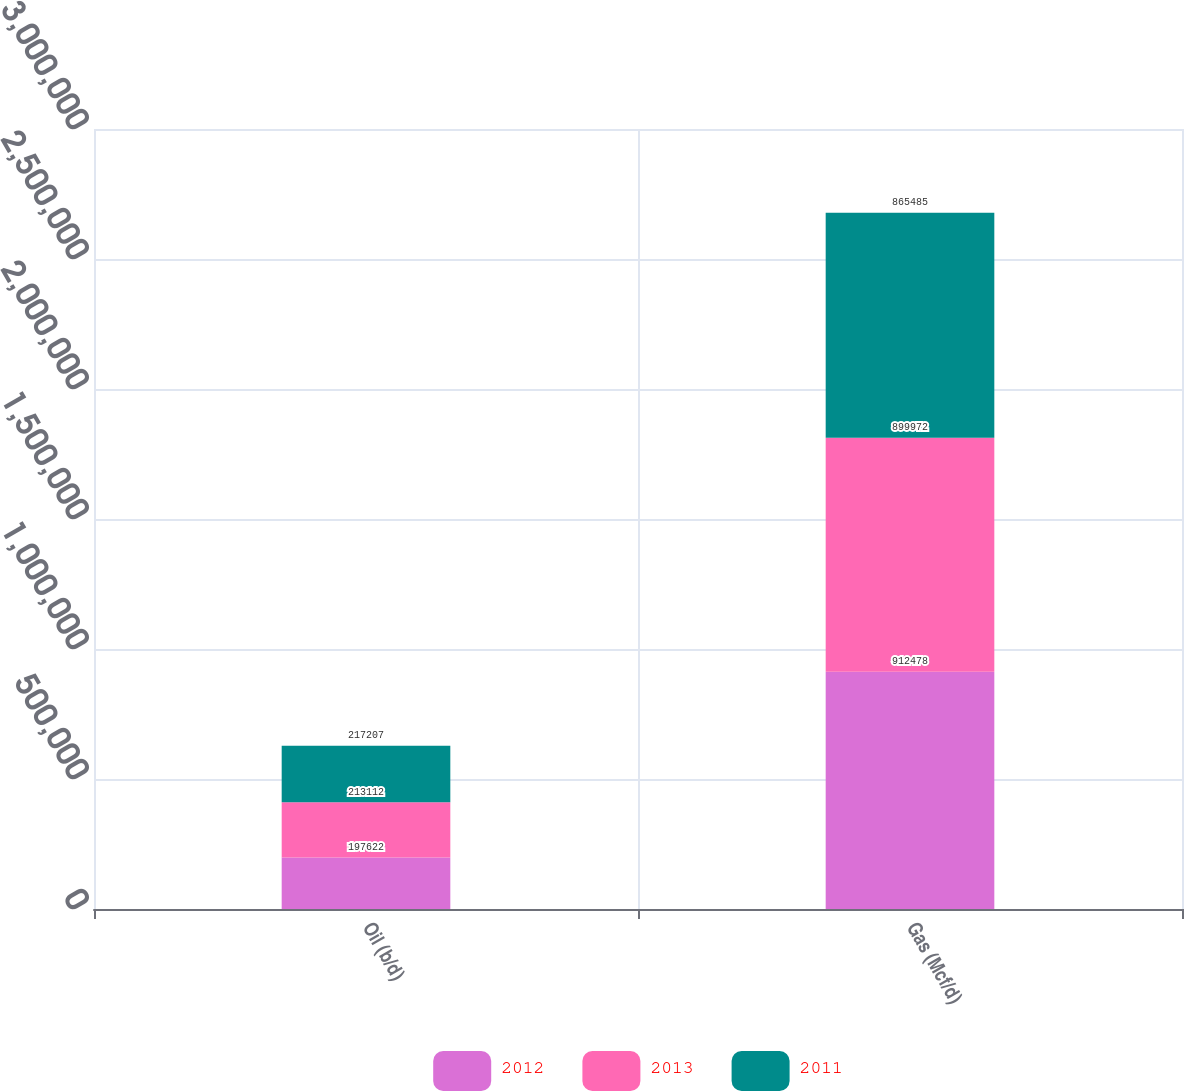<chart> <loc_0><loc_0><loc_500><loc_500><stacked_bar_chart><ecel><fcel>Oil (b/d)<fcel>Gas (Mcf/d)<nl><fcel>2012<fcel>197622<fcel>912478<nl><fcel>2013<fcel>213112<fcel>899972<nl><fcel>2011<fcel>217207<fcel>865485<nl></chart> 